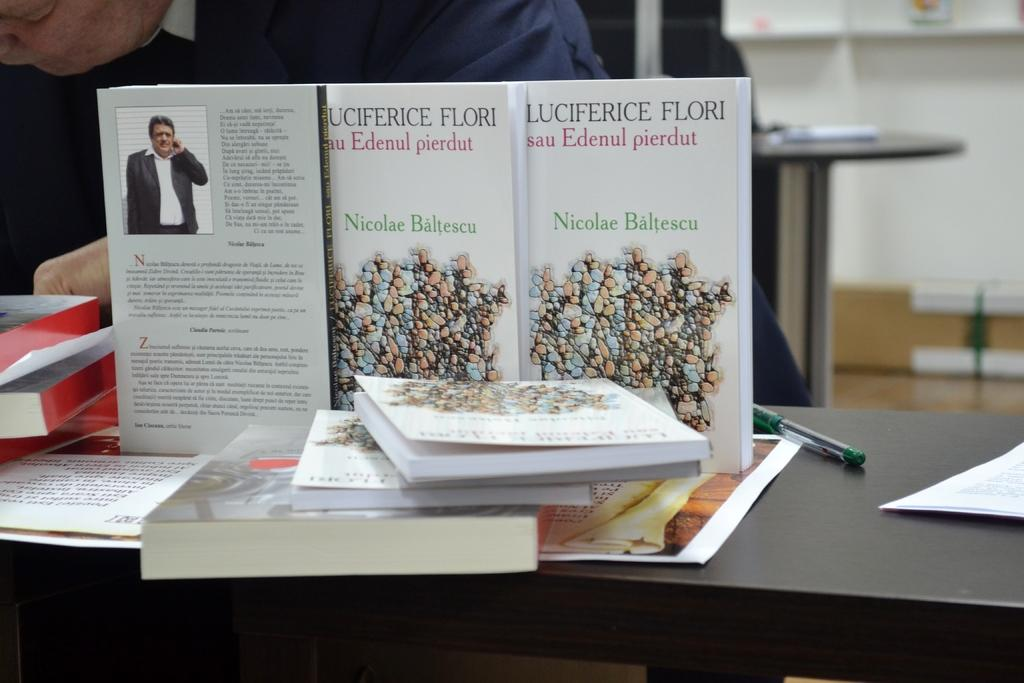<image>
Give a short and clear explanation of the subsequent image. a white book on a desk that is by Nicolae Baltescu 